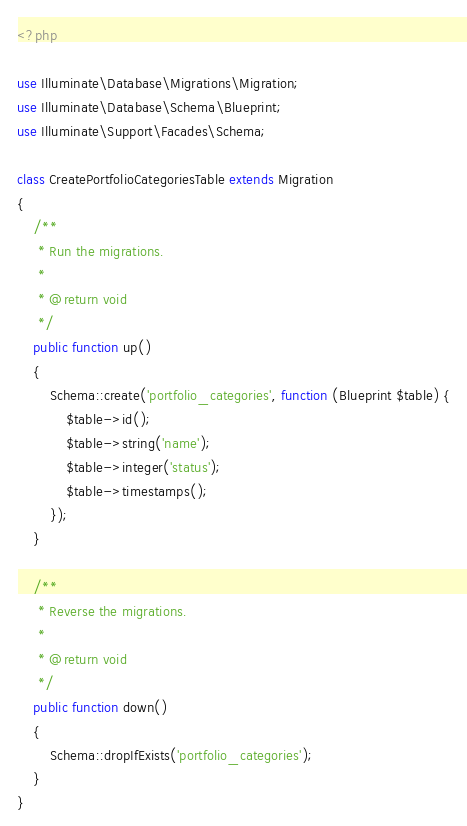Convert code to text. <code><loc_0><loc_0><loc_500><loc_500><_PHP_><?php

use Illuminate\Database\Migrations\Migration;
use Illuminate\Database\Schema\Blueprint;
use Illuminate\Support\Facades\Schema;

class CreatePortfolioCategoriesTable extends Migration
{
    /**
     * Run the migrations.
     *
     * @return void
     */
    public function up()
    {
        Schema::create('portfolio_categories', function (Blueprint $table) {
            $table->id();
            $table->string('name');
            $table->integer('status');
            $table->timestamps();
        });
    }

    /**
     * Reverse the migrations.
     *
     * @return void
     */
    public function down()
    {
        Schema::dropIfExists('portfolio_categories');
    }
}
</code> 